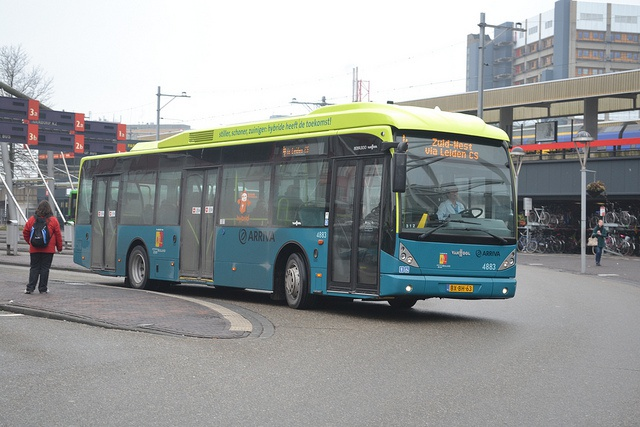Describe the objects in this image and their specific colors. I can see bus in white, gray, black, and blue tones, people in white, black, maroon, gray, and brown tones, people in white, gray, and purple tones, people in white, gray, and darkgray tones, and backpack in white, black, gray, and darkblue tones in this image. 